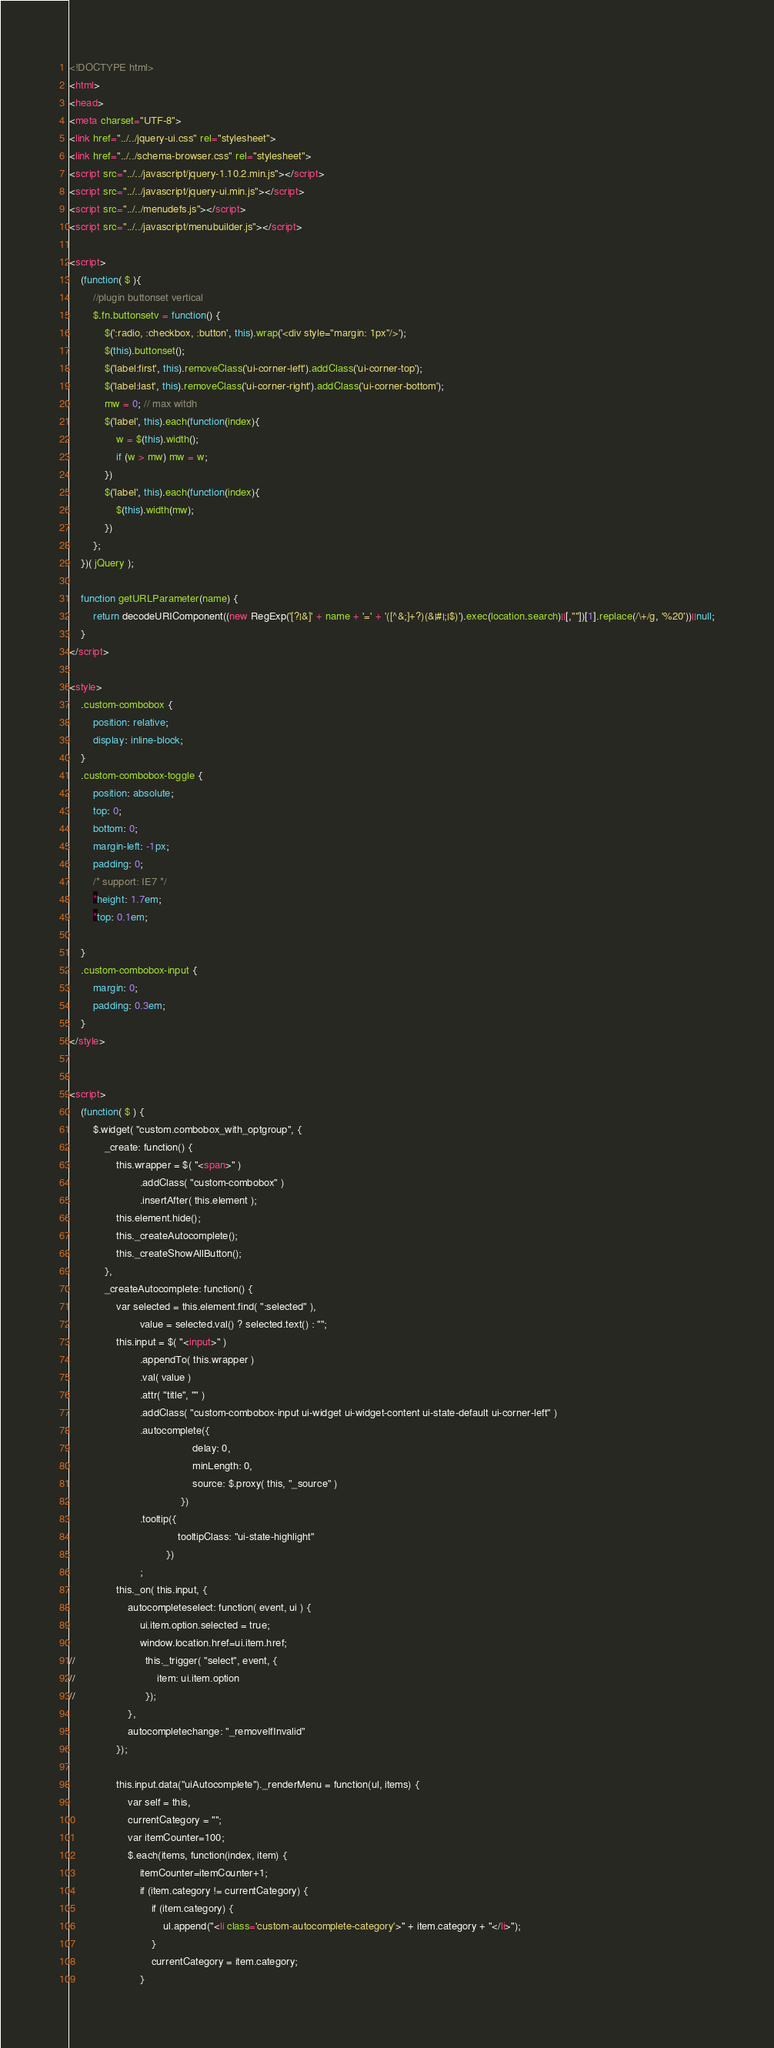Convert code to text. <code><loc_0><loc_0><loc_500><loc_500><_HTML_><!DOCTYPE html>
<html>
<head>
<meta charset="UTF-8">
<link href="../../jquery-ui.css" rel="stylesheet">
<link href="../../schema-browser.css" rel="stylesheet">
<script src="../../javascript/jquery-1.10.2.min.js"></script>
<script src="../../javascript/jquery-ui.min.js"></script>
<script src="../../menudefs.js"></script>
<script src="../../javascript/menubuilder.js"></script>

<script>
    (function( $ ){
        //plugin buttonset vertical
        $.fn.buttonsetv = function() {
            $(':radio, :checkbox, :button', this).wrap('<div style="margin: 1px"/>');
            $(this).buttonset();
            $('label:first', this).removeClass('ui-corner-left').addClass('ui-corner-top');
            $('label:last', this).removeClass('ui-corner-right').addClass('ui-corner-bottom');
            mw = 0; // max witdh
            $('label', this).each(function(index){
                w = $(this).width();
                if (w > mw) mw = w;
            })
            $('label', this).each(function(index){
                $(this).width(mw);
            })
        };
    })( jQuery );

    function getURLParameter(name) {
        return decodeURIComponent((new RegExp('[?|&]' + name + '=' + '([^&;]+?)(&|#|;|$)').exec(location.search)||[,""])[1].replace(/\+/g, '%20'))||null;
    }
</script>

<style>
    .custom-combobox {
        position: relative;
        display: inline-block;
    }
    .custom-combobox-toggle {
        position: absolute;
        top: 0;
        bottom: 0;
        margin-left: -1px;
        padding: 0;
        /* support: IE7 */
        *height: 1.7em;
        *top: 0.1em;

    }
    .custom-combobox-input {
        margin: 0;
        padding: 0.3em;
    }
</style>


<script>
    (function( $ ) {
        $.widget( "custom.combobox_with_optgroup", {
            _create: function() {
                this.wrapper = $( "<span>" )
                        .addClass( "custom-combobox" )
                        .insertAfter( this.element );
                this.element.hide();
                this._createAutocomplete();
                this._createShowAllButton();
            },
            _createAutocomplete: function() {
                var selected = this.element.find( ":selected" ),
                        value = selected.val() ? selected.text() : "";
                this.input = $( "<input>" )
                        .appendTo( this.wrapper )
                        .val( value )
                        .attr( "title", "" )
                        .addClass( "custom-combobox-input ui-widget ui-widget-content ui-state-default ui-corner-left" )
                        .autocomplete({
                                          delay: 0,
                                          minLength: 0,
                                          source: $.proxy( this, "_source" )
                                      })
                        .tooltip({
                                     tooltipClass: "ui-state-highlight"
                                 })
                        ;
                this._on( this.input, {
                    autocompleteselect: function( event, ui ) {
                        ui.item.option.selected = true;
                        window.location.href=ui.item.href;
//                        this._trigger( "select", event, {
//                            item: ui.item.option
//                        });
                    },
                    autocompletechange: "_removeIfInvalid"
                });

                this.input.data("uiAutocomplete")._renderMenu = function(ul, items) {
                    var self = this,
                    currentCategory = "";
                    var itemCounter=100;
                    $.each(items, function(index, item) {
                        itemCounter=itemCounter+1;
                        if (item.category != currentCategory) {
                            if (item.category) {
                                ul.append("<li class='custom-autocomplete-category'>" + item.category + "</li>");
                            }
                            currentCategory = item.category;
                        }</code> 